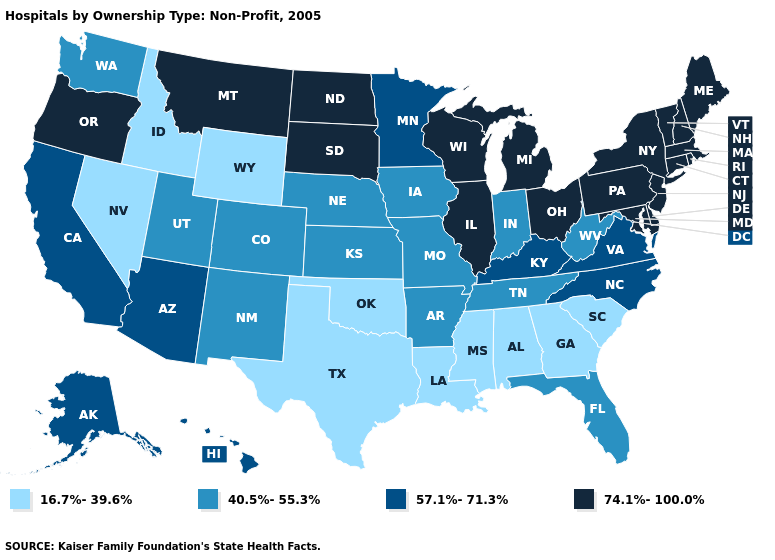Among the states that border Florida , which have the lowest value?
Concise answer only. Alabama, Georgia. What is the value of Maryland?
Answer briefly. 74.1%-100.0%. What is the value of Wisconsin?
Be succinct. 74.1%-100.0%. Is the legend a continuous bar?
Give a very brief answer. No. Among the states that border Washington , which have the highest value?
Keep it brief. Oregon. Name the states that have a value in the range 40.5%-55.3%?
Be succinct. Arkansas, Colorado, Florida, Indiana, Iowa, Kansas, Missouri, Nebraska, New Mexico, Tennessee, Utah, Washington, West Virginia. What is the highest value in the South ?
Concise answer only. 74.1%-100.0%. Name the states that have a value in the range 74.1%-100.0%?
Be succinct. Connecticut, Delaware, Illinois, Maine, Maryland, Massachusetts, Michigan, Montana, New Hampshire, New Jersey, New York, North Dakota, Ohio, Oregon, Pennsylvania, Rhode Island, South Dakota, Vermont, Wisconsin. What is the value of Alabama?
Answer briefly. 16.7%-39.6%. Name the states that have a value in the range 16.7%-39.6%?
Short answer required. Alabama, Georgia, Idaho, Louisiana, Mississippi, Nevada, Oklahoma, South Carolina, Texas, Wyoming. Which states have the lowest value in the South?
Keep it brief. Alabama, Georgia, Louisiana, Mississippi, Oklahoma, South Carolina, Texas. Which states have the lowest value in the USA?
Keep it brief. Alabama, Georgia, Idaho, Louisiana, Mississippi, Nevada, Oklahoma, South Carolina, Texas, Wyoming. Name the states that have a value in the range 16.7%-39.6%?
Keep it brief. Alabama, Georgia, Idaho, Louisiana, Mississippi, Nevada, Oklahoma, South Carolina, Texas, Wyoming. Which states have the highest value in the USA?
Be succinct. Connecticut, Delaware, Illinois, Maine, Maryland, Massachusetts, Michigan, Montana, New Hampshire, New Jersey, New York, North Dakota, Ohio, Oregon, Pennsylvania, Rhode Island, South Dakota, Vermont, Wisconsin. Name the states that have a value in the range 16.7%-39.6%?
Keep it brief. Alabama, Georgia, Idaho, Louisiana, Mississippi, Nevada, Oklahoma, South Carolina, Texas, Wyoming. 